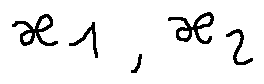<formula> <loc_0><loc_0><loc_500><loc_500>x _ { 1 } , x _ { 2 }</formula> 